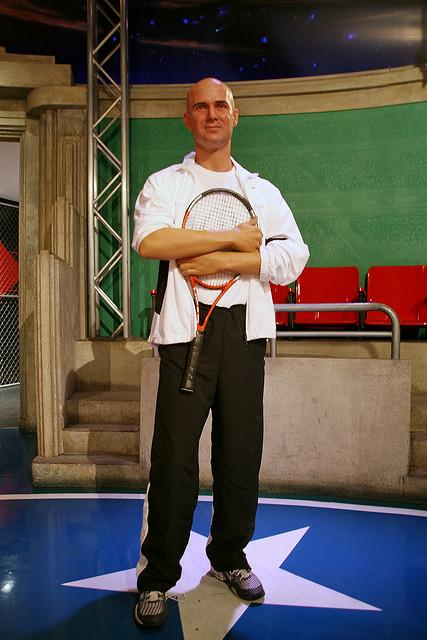What sports equipment is the man holding? Please explain your reasoning. tennis. A man stands on front of a green chalkboard hugging a tennis racket to his chest. 